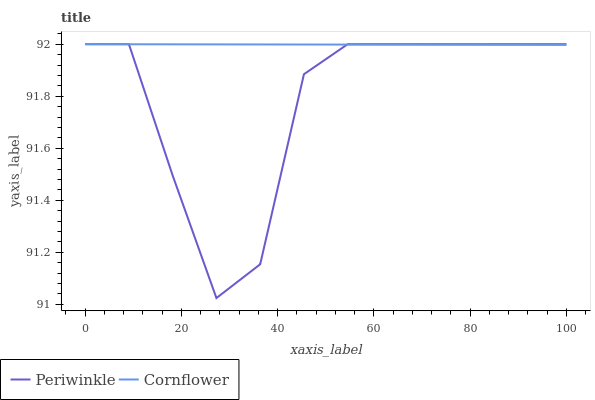Does Periwinkle have the maximum area under the curve?
Answer yes or no. No. Is Periwinkle the smoothest?
Answer yes or no. No. 